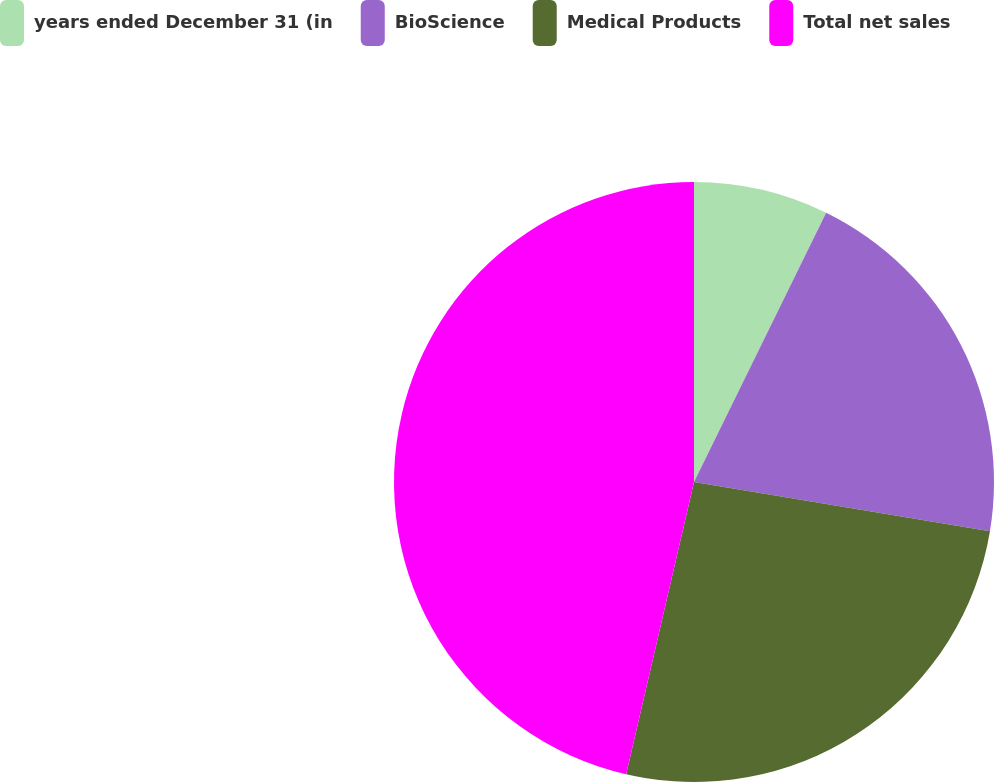<chart> <loc_0><loc_0><loc_500><loc_500><pie_chart><fcel>years ended December 31 (in<fcel>BioScience<fcel>Medical Products<fcel>Total net sales<nl><fcel>7.26%<fcel>20.36%<fcel>26.01%<fcel>46.37%<nl></chart> 